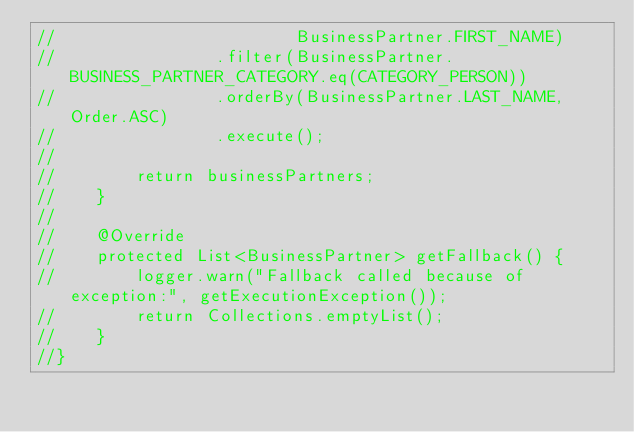<code> <loc_0><loc_0><loc_500><loc_500><_Java_>//                        BusinessPartner.FIRST_NAME)
//                .filter(BusinessPartner.BUSINESS_PARTNER_CATEGORY.eq(CATEGORY_PERSON))
//                .orderBy(BusinessPartner.LAST_NAME, Order.ASC)
//                .execute();
//
//        return businessPartners;
//    }
//
//    @Override
//    protected List<BusinessPartner> getFallback() {
//        logger.warn("Fallback called because of exception:", getExecutionException());
//        return Collections.emptyList();
//    }
//}
</code> 